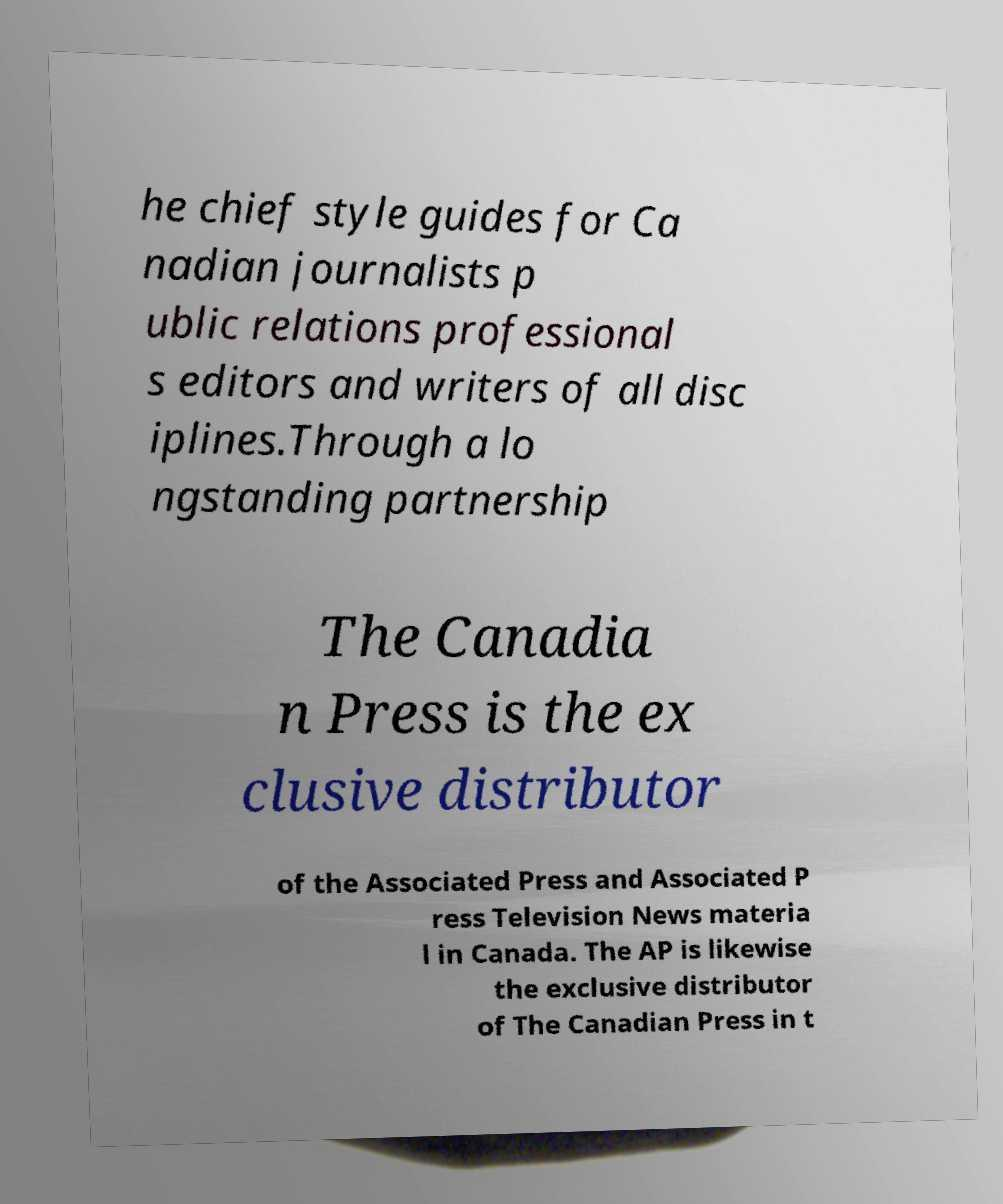What messages or text are displayed in this image? I need them in a readable, typed format. he chief style guides for Ca nadian journalists p ublic relations professional s editors and writers of all disc iplines.Through a lo ngstanding partnership The Canadia n Press is the ex clusive distributor of the Associated Press and Associated P ress Television News materia l in Canada. The AP is likewise the exclusive distributor of The Canadian Press in t 